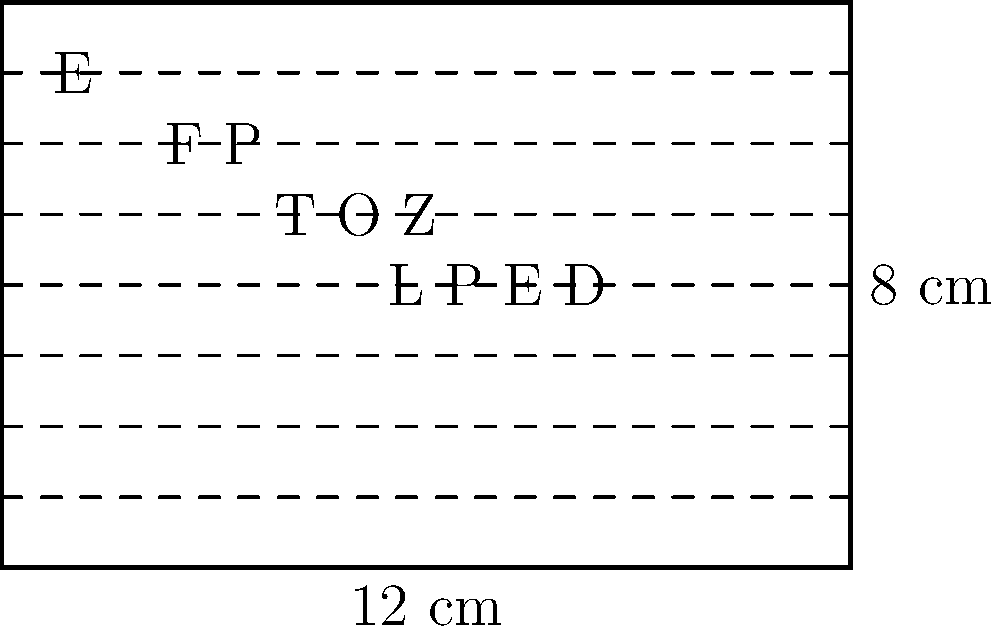An eye chart used in optometry exams is rectangular in shape, measuring 12 cm in width and 8 cm in height. What is the perimeter of this eye chart? To find the perimeter of the rectangular eye chart, we need to follow these steps:

1) Recall the formula for the perimeter of a rectangle:
   $$ P = 2l + 2w $$
   where $P$ is the perimeter, $l$ is the length (or height in this case), and $w$ is the width.

2) We are given:
   Width ($w$) = 12 cm
   Height ($l$) = 8 cm

3) Let's substitute these values into our formula:
   $$ P = 2(8 \text{ cm}) + 2(12 \text{ cm}) $$

4) Simplify:
   $$ P = 16 \text{ cm} + 24 \text{ cm} $$

5) Calculate the final result:
   $$ P = 40 \text{ cm} $$

Therefore, the perimeter of the eye chart is 40 cm.
Answer: 40 cm 